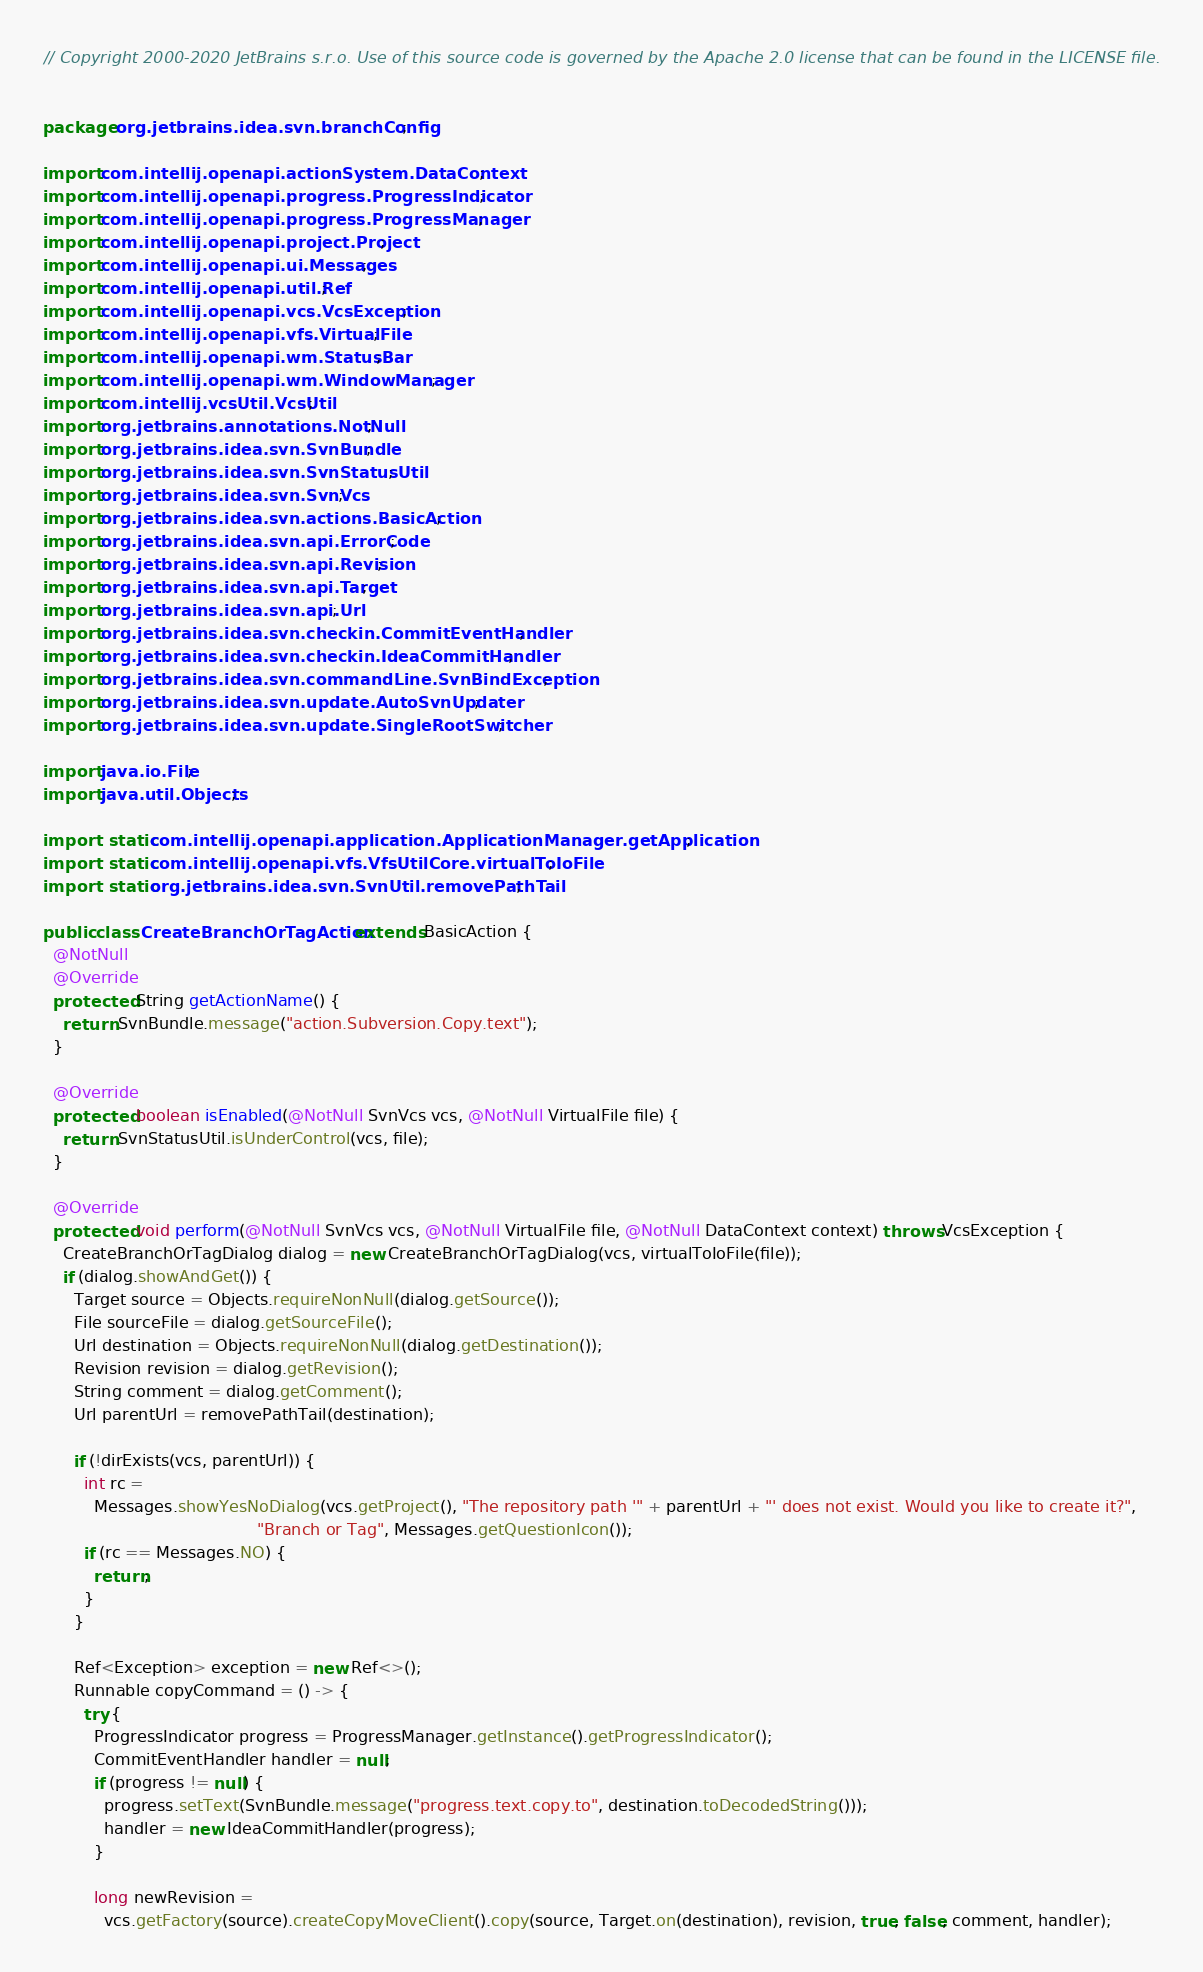Convert code to text. <code><loc_0><loc_0><loc_500><loc_500><_Java_>// Copyright 2000-2020 JetBrains s.r.o. Use of this source code is governed by the Apache 2.0 license that can be found in the LICENSE file.


package org.jetbrains.idea.svn.branchConfig;

import com.intellij.openapi.actionSystem.DataContext;
import com.intellij.openapi.progress.ProgressIndicator;
import com.intellij.openapi.progress.ProgressManager;
import com.intellij.openapi.project.Project;
import com.intellij.openapi.ui.Messages;
import com.intellij.openapi.util.Ref;
import com.intellij.openapi.vcs.VcsException;
import com.intellij.openapi.vfs.VirtualFile;
import com.intellij.openapi.wm.StatusBar;
import com.intellij.openapi.wm.WindowManager;
import com.intellij.vcsUtil.VcsUtil;
import org.jetbrains.annotations.NotNull;
import org.jetbrains.idea.svn.SvnBundle;
import org.jetbrains.idea.svn.SvnStatusUtil;
import org.jetbrains.idea.svn.SvnVcs;
import org.jetbrains.idea.svn.actions.BasicAction;
import org.jetbrains.idea.svn.api.ErrorCode;
import org.jetbrains.idea.svn.api.Revision;
import org.jetbrains.idea.svn.api.Target;
import org.jetbrains.idea.svn.api.Url;
import org.jetbrains.idea.svn.checkin.CommitEventHandler;
import org.jetbrains.idea.svn.checkin.IdeaCommitHandler;
import org.jetbrains.idea.svn.commandLine.SvnBindException;
import org.jetbrains.idea.svn.update.AutoSvnUpdater;
import org.jetbrains.idea.svn.update.SingleRootSwitcher;

import java.io.File;
import java.util.Objects;

import static com.intellij.openapi.application.ApplicationManager.getApplication;
import static com.intellij.openapi.vfs.VfsUtilCore.virtualToIoFile;
import static org.jetbrains.idea.svn.SvnUtil.removePathTail;

public class CreateBranchOrTagAction extends BasicAction {
  @NotNull
  @Override
  protected String getActionName() {
    return SvnBundle.message("action.Subversion.Copy.text");
  }

  @Override
  protected boolean isEnabled(@NotNull SvnVcs vcs, @NotNull VirtualFile file) {
    return SvnStatusUtil.isUnderControl(vcs, file);
  }

  @Override
  protected void perform(@NotNull SvnVcs vcs, @NotNull VirtualFile file, @NotNull DataContext context) throws VcsException {
    CreateBranchOrTagDialog dialog = new CreateBranchOrTagDialog(vcs, virtualToIoFile(file));
    if (dialog.showAndGet()) {
      Target source = Objects.requireNonNull(dialog.getSource());
      File sourceFile = dialog.getSourceFile();
      Url destination = Objects.requireNonNull(dialog.getDestination());
      Revision revision = dialog.getRevision();
      String comment = dialog.getComment();
      Url parentUrl = removePathTail(destination);

      if (!dirExists(vcs, parentUrl)) {
        int rc =
          Messages.showYesNoDialog(vcs.getProject(), "The repository path '" + parentUrl + "' does not exist. Would you like to create it?",
                                          "Branch or Tag", Messages.getQuestionIcon());
        if (rc == Messages.NO) {
          return;
        }
      }

      Ref<Exception> exception = new Ref<>();
      Runnable copyCommand = () -> {
        try {
          ProgressIndicator progress = ProgressManager.getInstance().getProgressIndicator();
          CommitEventHandler handler = null;
          if (progress != null) {
            progress.setText(SvnBundle.message("progress.text.copy.to", destination.toDecodedString()));
            handler = new IdeaCommitHandler(progress);
          }

          long newRevision =
            vcs.getFactory(source).createCopyMoveClient().copy(source, Target.on(destination), revision, true, false, comment, handler);
</code> 